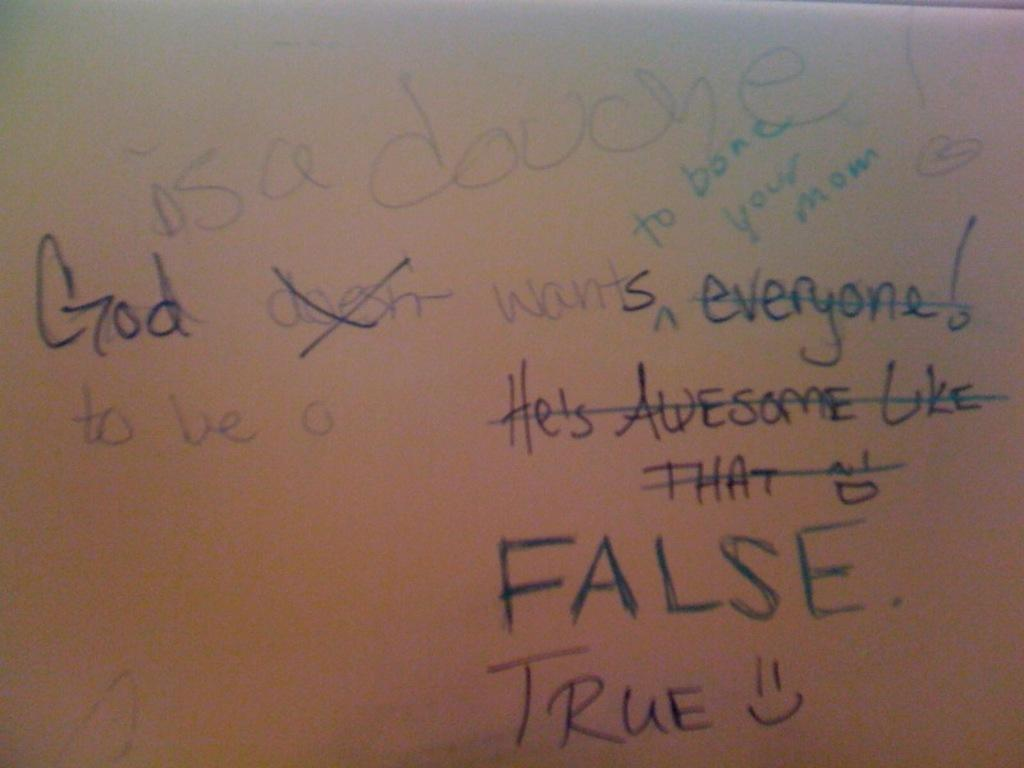What is the main object in the center of the image? There is a board in the center of the image. What can be seen on the board? Text is written on the board. How many mice are running along the coast in the image? There are no mice or coast visible in the image; it only features a board with text on it. 